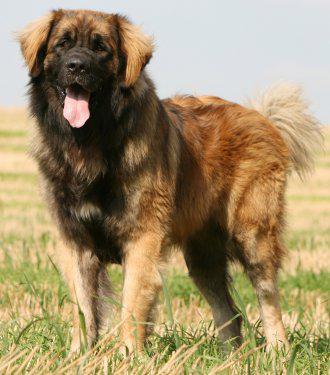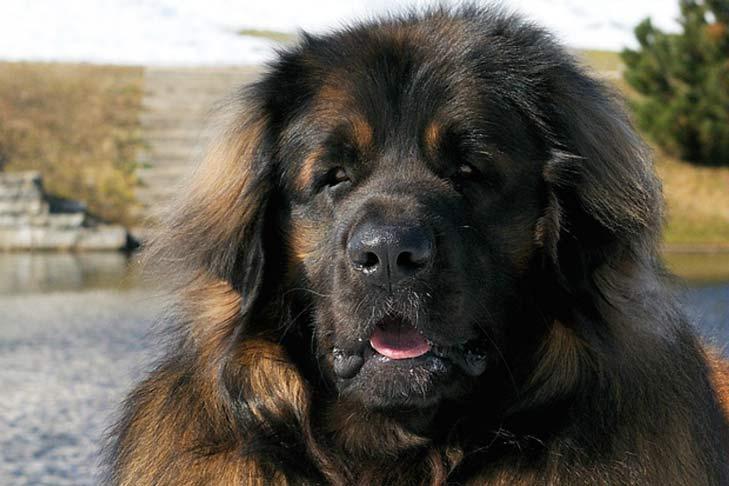The first image is the image on the left, the second image is the image on the right. Analyze the images presented: Is the assertion "An image shows at least one dog that is walking forward, with one front paw in front of the other." valid? Answer yes or no. No. 